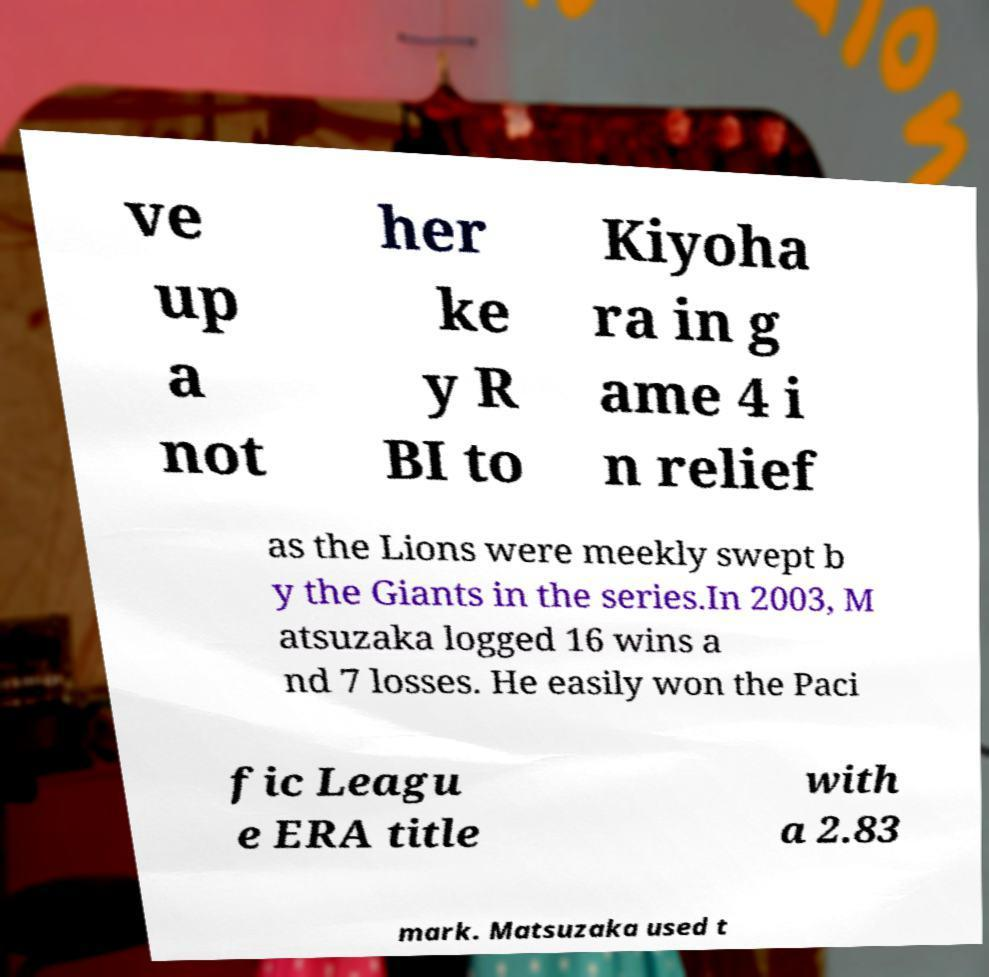I need the written content from this picture converted into text. Can you do that? ve up a not her ke y R BI to Kiyoha ra in g ame 4 i n relief as the Lions were meekly swept b y the Giants in the series.In 2003, M atsuzaka logged 16 wins a nd 7 losses. He easily won the Paci fic Leagu e ERA title with a 2.83 mark. Matsuzaka used t 